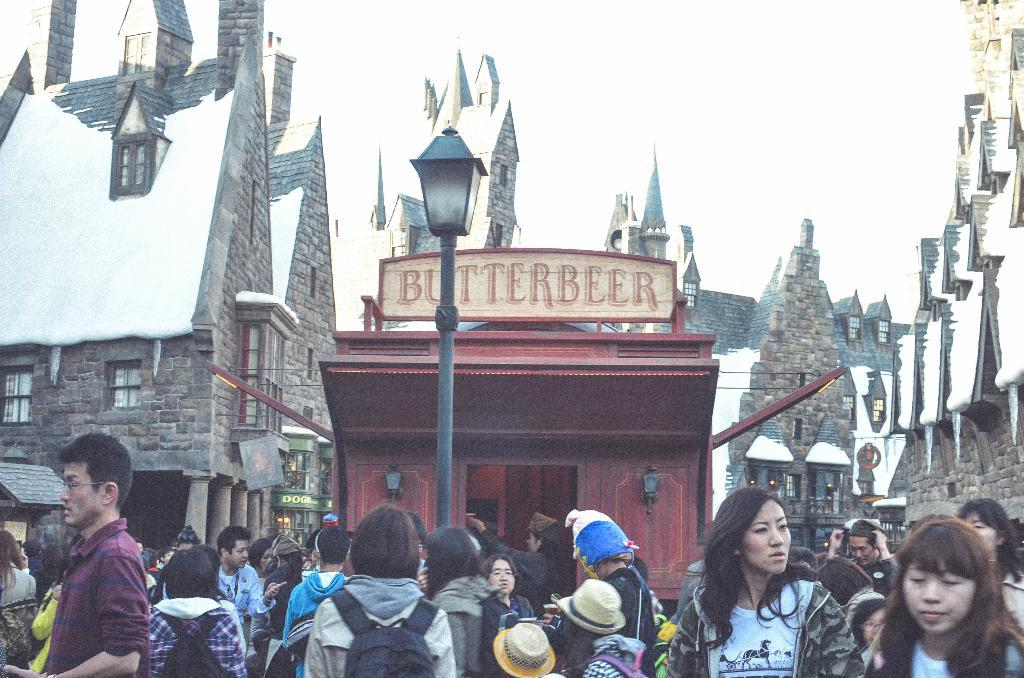What is the condition of the buildings in the image? The buildings in the image are covered with snow. What can be seen in the middle of the image? There is a pole in the middle of the image. What is visible at the top of the image? The sky is visible at the top of the image. What is happening at the bottom of the image? There is a large crowd at the bottom of the image. Where is the seashore in the image? There is no seashore present in the image. How many lizards can be seen in the crowd at the bottom of the image? There are no lizards present in the image. 